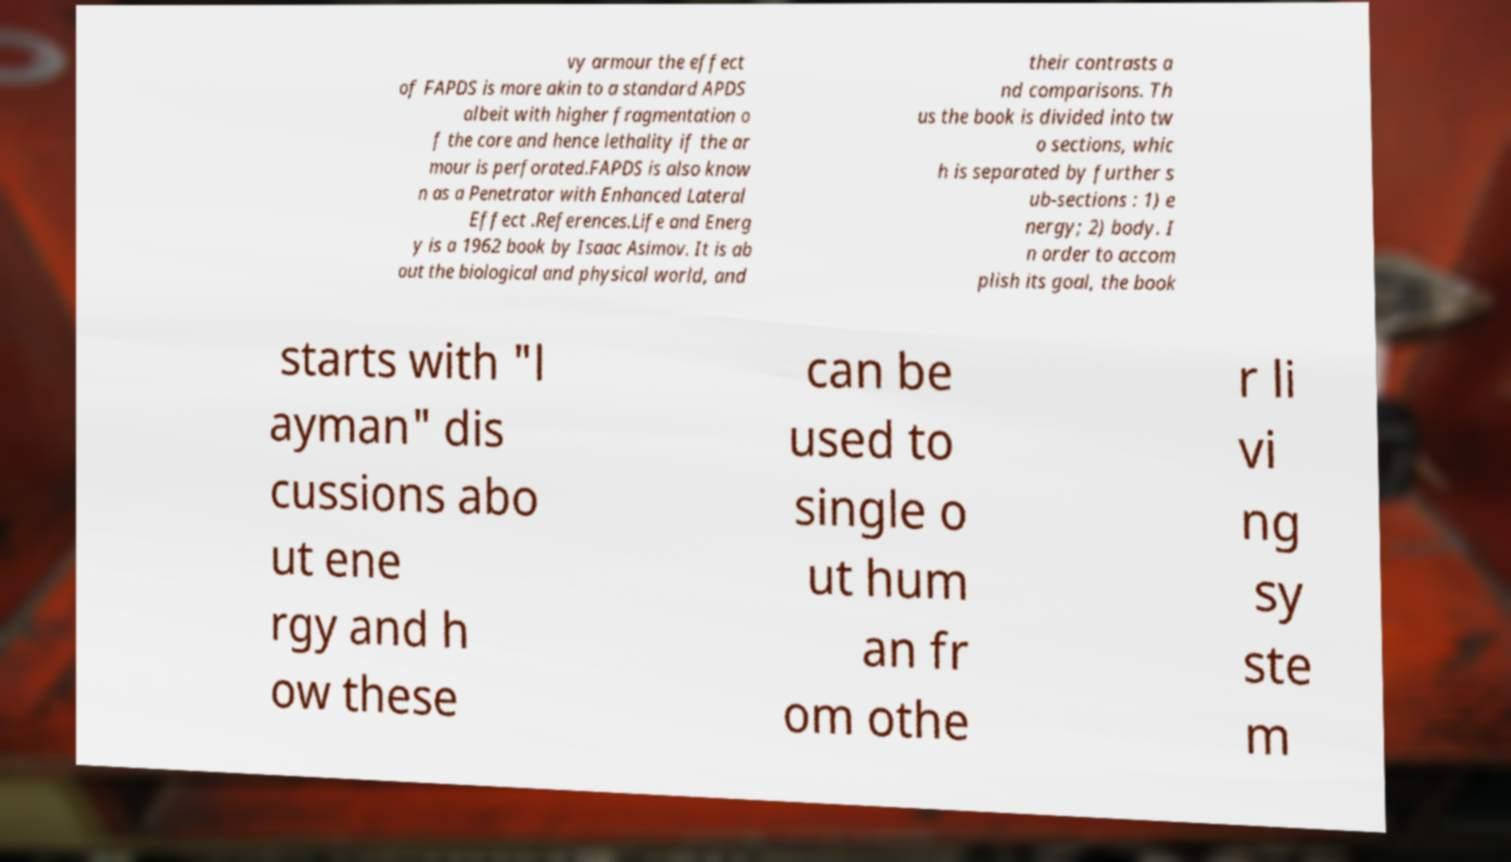Please read and relay the text visible in this image. What does it say? vy armour the effect of FAPDS is more akin to a standard APDS albeit with higher fragmentation o f the core and hence lethality if the ar mour is perforated.FAPDS is also know n as a Penetrator with Enhanced Lateral Effect .References.Life and Energ y is a 1962 book by Isaac Asimov. It is ab out the biological and physical world, and their contrasts a nd comparisons. Th us the book is divided into tw o sections, whic h is separated by further s ub-sections : 1) e nergy; 2) body. I n order to accom plish its goal, the book starts with "l ayman" dis cussions abo ut ene rgy and h ow these can be used to single o ut hum an fr om othe r li vi ng sy ste m 